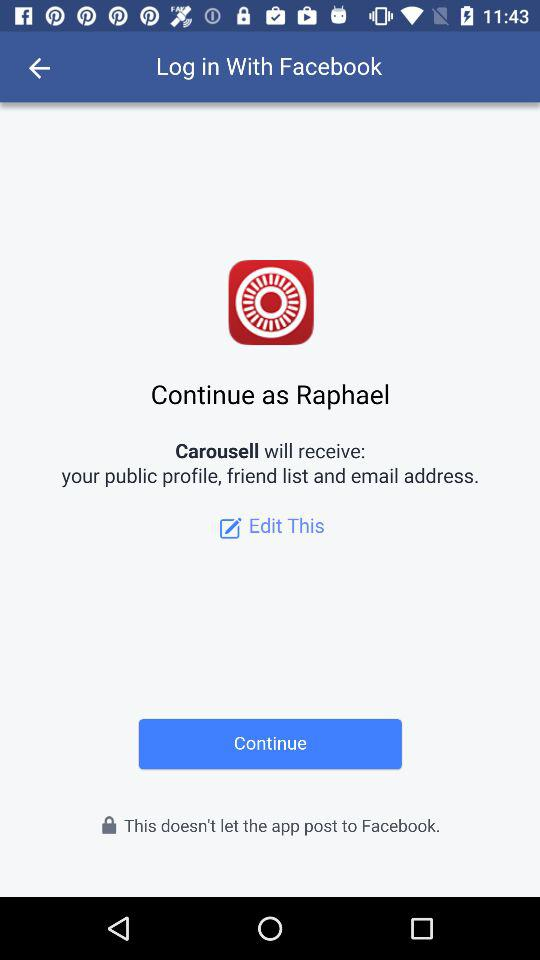What is the name of the user? The name of the user is Raphael. 